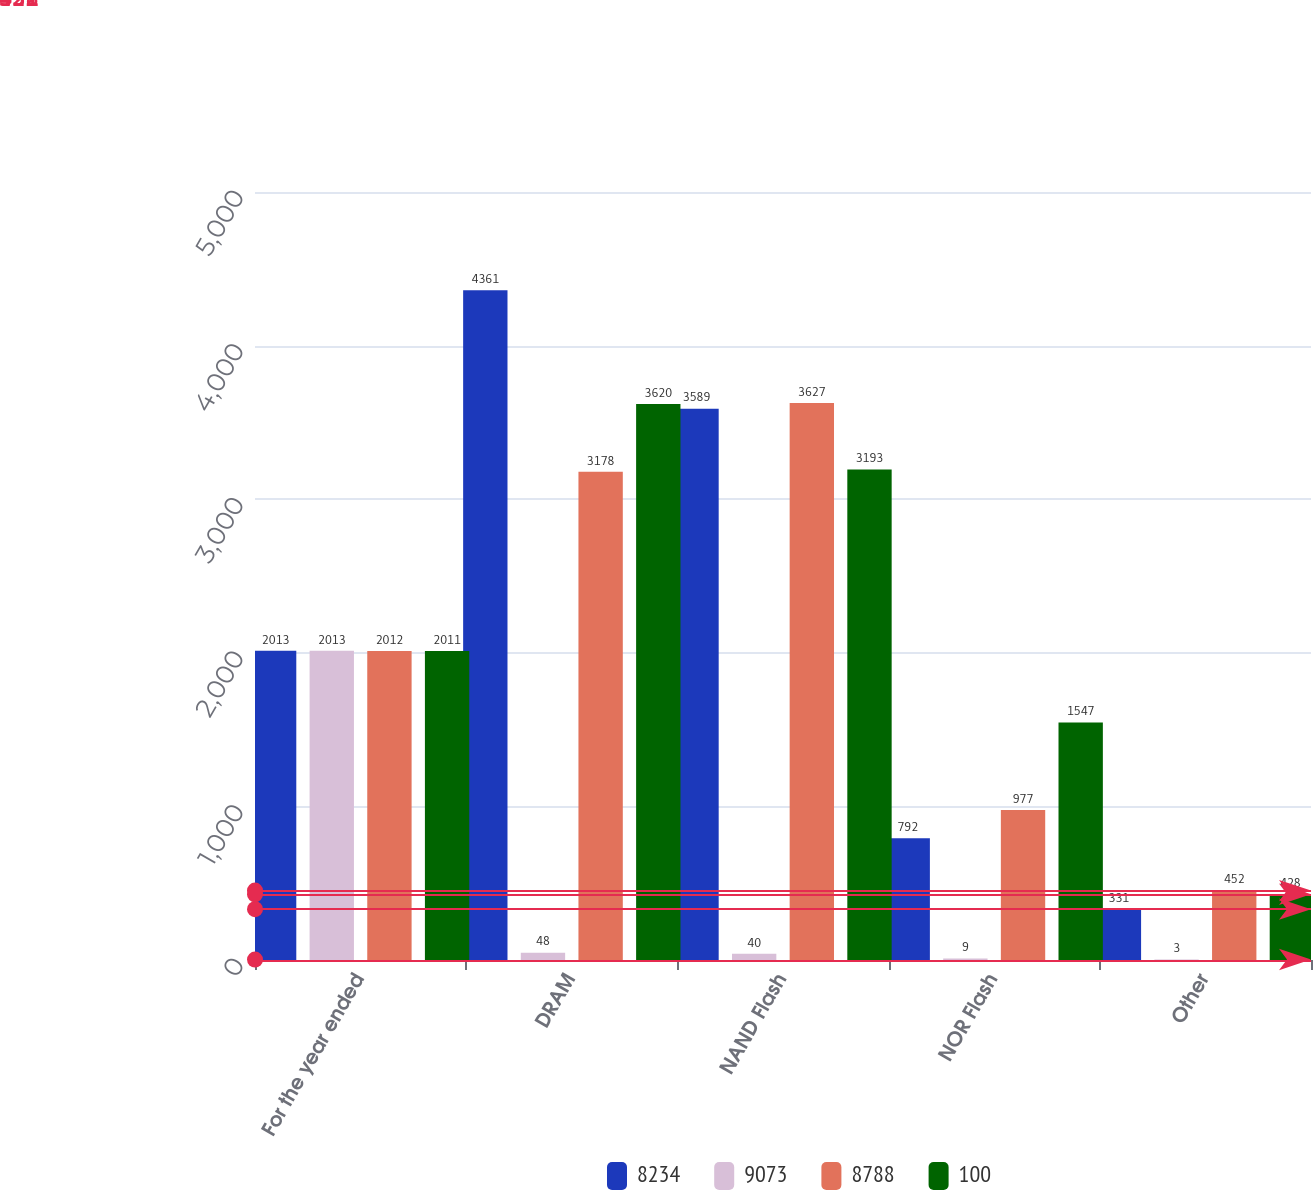Convert chart to OTSL. <chart><loc_0><loc_0><loc_500><loc_500><stacked_bar_chart><ecel><fcel>For the year ended<fcel>DRAM<fcel>NAND Flash<fcel>NOR Flash<fcel>Other<nl><fcel>8234<fcel>2013<fcel>4361<fcel>3589<fcel>792<fcel>331<nl><fcel>9073<fcel>2013<fcel>48<fcel>40<fcel>9<fcel>3<nl><fcel>8788<fcel>2012<fcel>3178<fcel>3627<fcel>977<fcel>452<nl><fcel>100<fcel>2011<fcel>3620<fcel>3193<fcel>1547<fcel>428<nl></chart> 